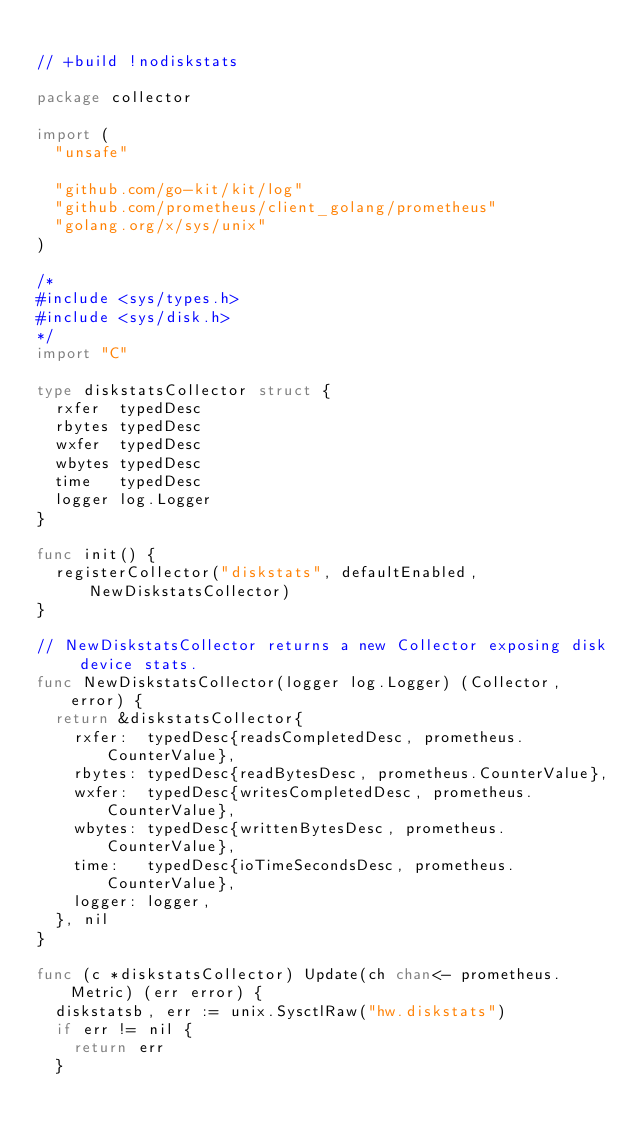<code> <loc_0><loc_0><loc_500><loc_500><_Go_>
// +build !nodiskstats

package collector

import (
	"unsafe"

	"github.com/go-kit/kit/log"
	"github.com/prometheus/client_golang/prometheus"
	"golang.org/x/sys/unix"
)

/*
#include <sys/types.h>
#include <sys/disk.h>
*/
import "C"

type diskstatsCollector struct {
	rxfer  typedDesc
	rbytes typedDesc
	wxfer  typedDesc
	wbytes typedDesc
	time   typedDesc
	logger log.Logger
}

func init() {
	registerCollector("diskstats", defaultEnabled, NewDiskstatsCollector)
}

// NewDiskstatsCollector returns a new Collector exposing disk device stats.
func NewDiskstatsCollector(logger log.Logger) (Collector, error) {
	return &diskstatsCollector{
		rxfer:  typedDesc{readsCompletedDesc, prometheus.CounterValue},
		rbytes: typedDesc{readBytesDesc, prometheus.CounterValue},
		wxfer:  typedDesc{writesCompletedDesc, prometheus.CounterValue},
		wbytes: typedDesc{writtenBytesDesc, prometheus.CounterValue},
		time:   typedDesc{ioTimeSecondsDesc, prometheus.CounterValue},
		logger: logger,
	}, nil
}

func (c *diskstatsCollector) Update(ch chan<- prometheus.Metric) (err error) {
	diskstatsb, err := unix.SysctlRaw("hw.diskstats")
	if err != nil {
		return err
	}
</code> 